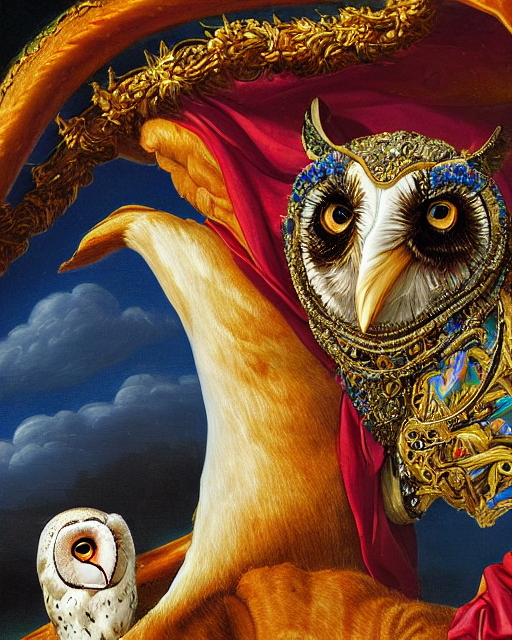Can you describe the style or art movement this image might be associated with? The image showcases an ornately adorned owl portrayed in a surrealist style, where fantastical scenes and creatures are depicted with photorealistic precision. Elements combined in an unexpected manner suggest a dreamlike or otherworldly scenario that is characteristic of surrealist art. 